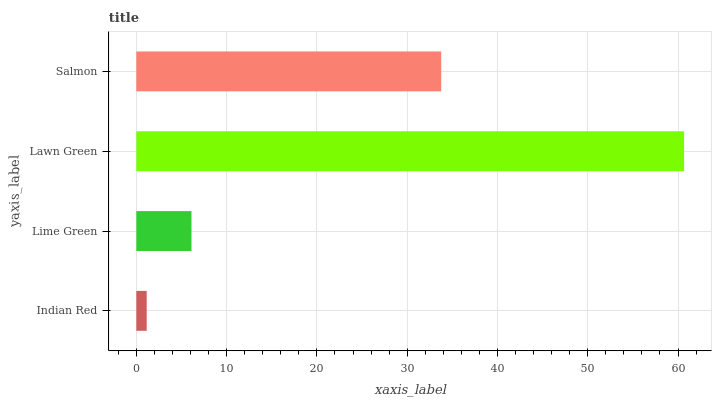Is Indian Red the minimum?
Answer yes or no. Yes. Is Lawn Green the maximum?
Answer yes or no. Yes. Is Lime Green the minimum?
Answer yes or no. No. Is Lime Green the maximum?
Answer yes or no. No. Is Lime Green greater than Indian Red?
Answer yes or no. Yes. Is Indian Red less than Lime Green?
Answer yes or no. Yes. Is Indian Red greater than Lime Green?
Answer yes or no. No. Is Lime Green less than Indian Red?
Answer yes or no. No. Is Salmon the high median?
Answer yes or no. Yes. Is Lime Green the low median?
Answer yes or no. Yes. Is Lime Green the high median?
Answer yes or no. No. Is Lawn Green the low median?
Answer yes or no. No. 